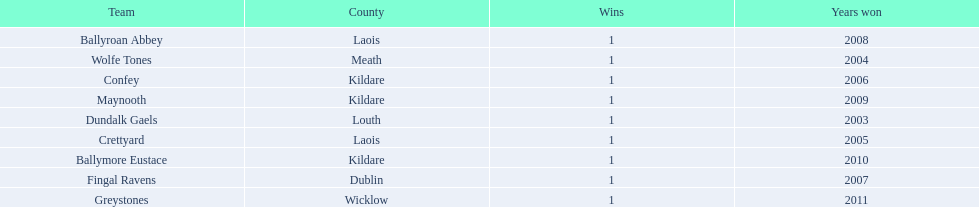What county is ballymore eustace from? Kildare. Besides convey, which other team is from the same county? Maynooth. 